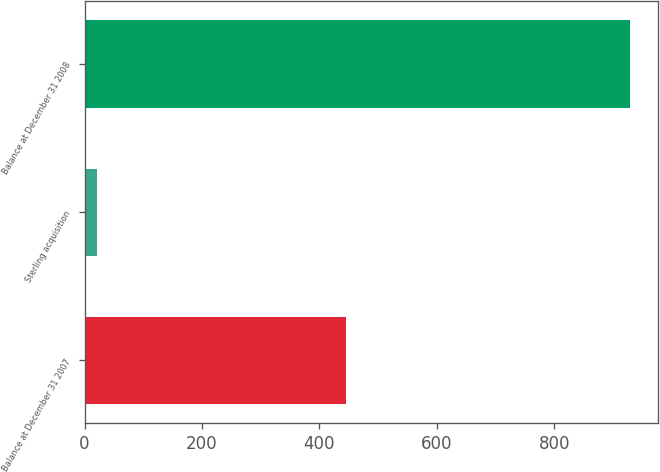Convert chart to OTSL. <chart><loc_0><loc_0><loc_500><loc_500><bar_chart><fcel>Balance at December 31 2007<fcel>Sterling acquisition<fcel>Balance at December 31 2008<nl><fcel>445<fcel>21<fcel>930<nl></chart> 